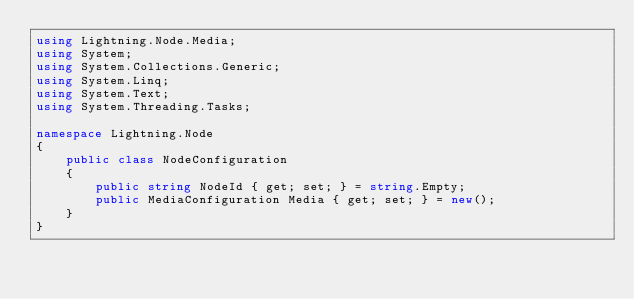<code> <loc_0><loc_0><loc_500><loc_500><_C#_>using Lightning.Node.Media;
using System;
using System.Collections.Generic;
using System.Linq;
using System.Text;
using System.Threading.Tasks;

namespace Lightning.Node
{
	public class NodeConfiguration
	{
		public string NodeId { get; set; } = string.Empty;
		public MediaConfiguration Media { get; set; } = new();
	}
}
</code> 